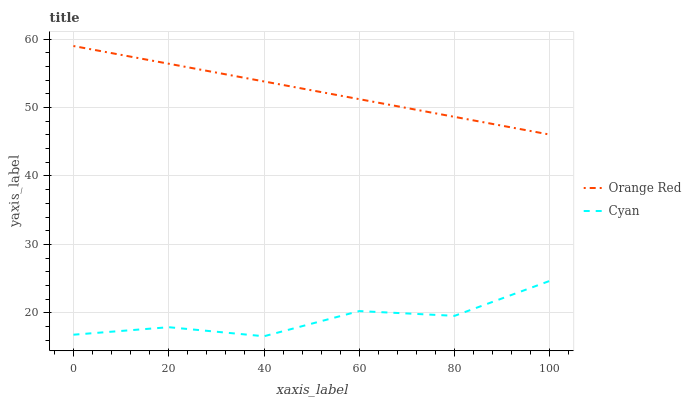Does Cyan have the minimum area under the curve?
Answer yes or no. Yes. Does Orange Red have the maximum area under the curve?
Answer yes or no. Yes. Does Orange Red have the minimum area under the curve?
Answer yes or no. No. Is Orange Red the smoothest?
Answer yes or no. Yes. Is Cyan the roughest?
Answer yes or no. Yes. Is Orange Red the roughest?
Answer yes or no. No. Does Cyan have the lowest value?
Answer yes or no. Yes. Does Orange Red have the lowest value?
Answer yes or no. No. Does Orange Red have the highest value?
Answer yes or no. Yes. Is Cyan less than Orange Red?
Answer yes or no. Yes. Is Orange Red greater than Cyan?
Answer yes or no. Yes. Does Cyan intersect Orange Red?
Answer yes or no. No. 